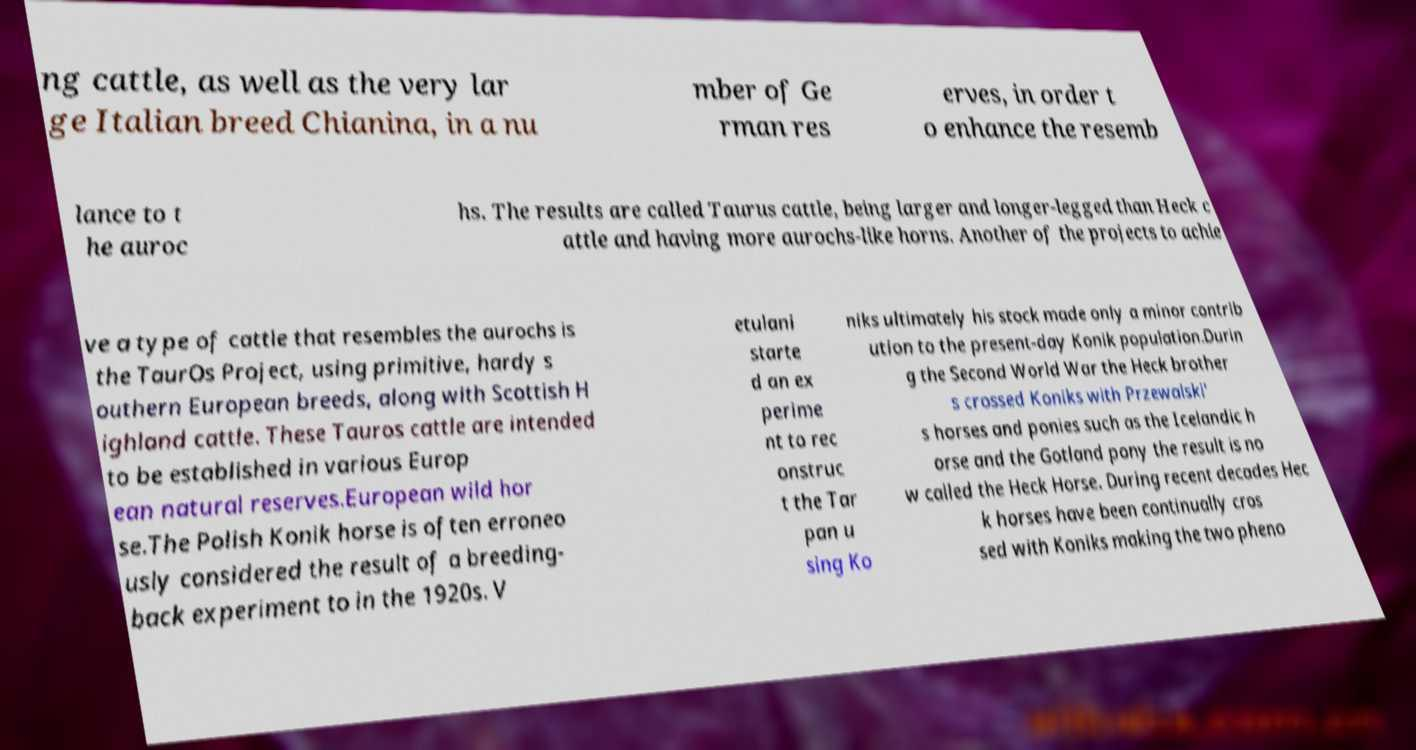Please read and relay the text visible in this image. What does it say? ng cattle, as well as the very lar ge Italian breed Chianina, in a nu mber of Ge rman res erves, in order t o enhance the resemb lance to t he auroc hs. The results are called Taurus cattle, being larger and longer-legged than Heck c attle and having more aurochs-like horns. Another of the projects to achie ve a type of cattle that resembles the aurochs is the TaurOs Project, using primitive, hardy s outhern European breeds, along with Scottish H ighland cattle. These Tauros cattle are intended to be established in various Europ ean natural reserves.European wild hor se.The Polish Konik horse is often erroneo usly considered the result of a breeding- back experiment to in the 1920s. V etulani starte d an ex perime nt to rec onstruc t the Tar pan u sing Ko niks ultimately his stock made only a minor contrib ution to the present-day Konik population.Durin g the Second World War the Heck brother s crossed Koniks with Przewalski' s horses and ponies such as the Icelandic h orse and the Gotland pony the result is no w called the Heck Horse. During recent decades Hec k horses have been continually cros sed with Koniks making the two pheno 